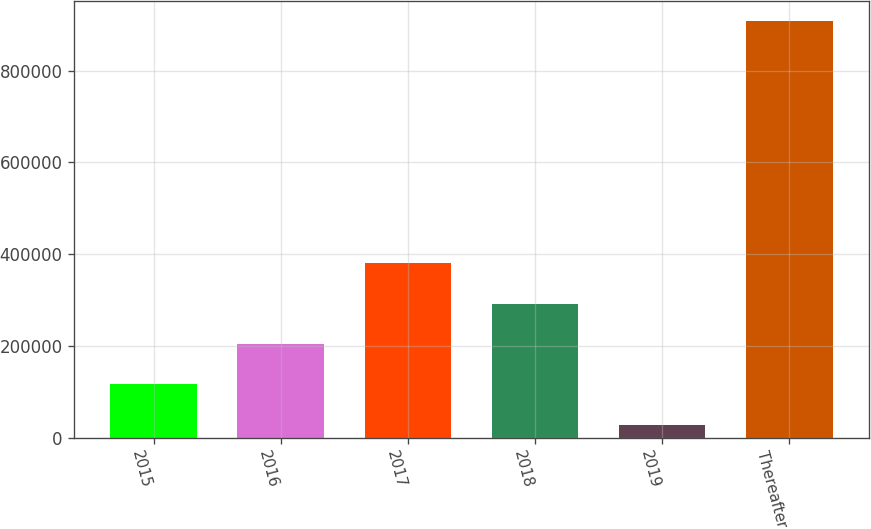Convert chart. <chart><loc_0><loc_0><loc_500><loc_500><bar_chart><fcel>2015<fcel>2016<fcel>2017<fcel>2018<fcel>2019<fcel>Thereafter<nl><fcel>116150<fcel>204035<fcel>379804<fcel>291919<fcel>28266<fcel>907110<nl></chart> 